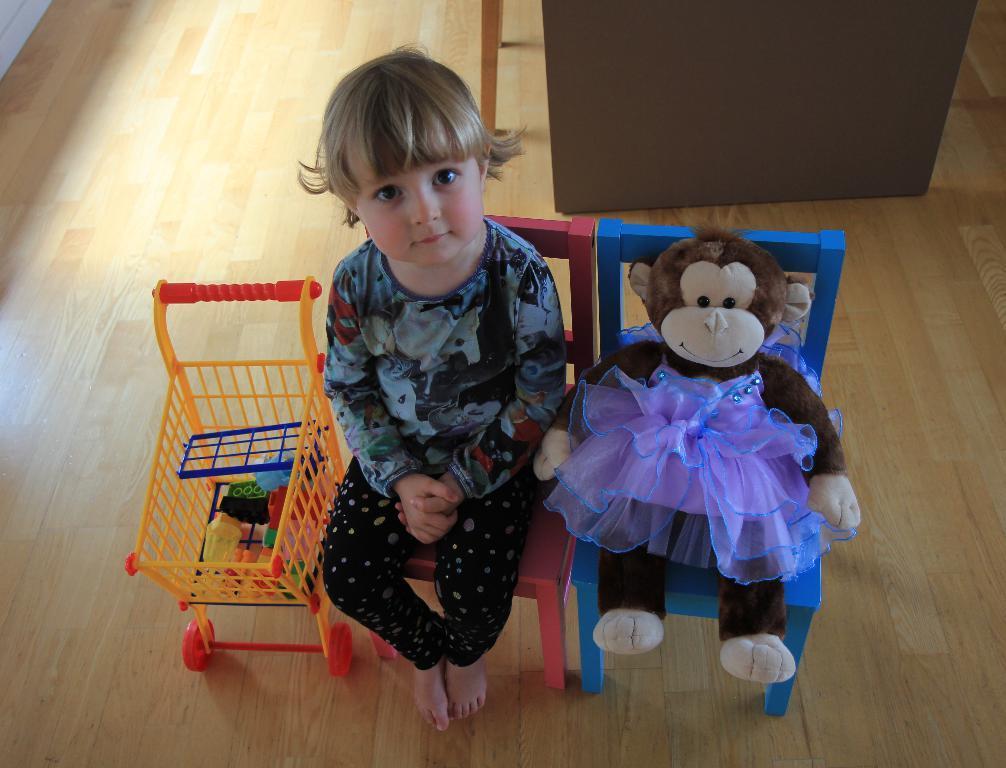Describe this image in one or two sentences. In the image on the wooden floor to the left corner there is a toy cart with few items in it. Beside the cart to the right side there is a girl sitting on the red chair. Beside her to the right there is a blue chair with toy monkey is sitting on it. At the top right of the image there is an item. 